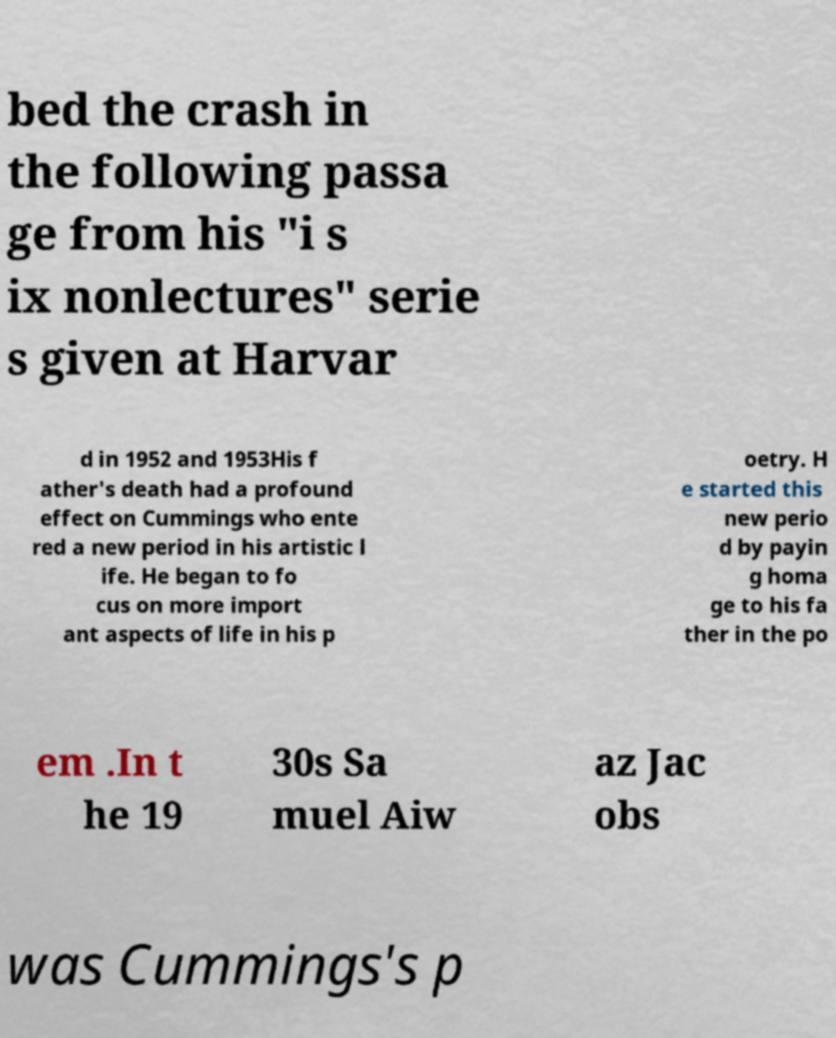Please identify and transcribe the text found in this image. bed the crash in the following passa ge from his "i s ix nonlectures" serie s given at Harvar d in 1952 and 1953His f ather's death had a profound effect on Cummings who ente red a new period in his artistic l ife. He began to fo cus on more import ant aspects of life in his p oetry. H e started this new perio d by payin g homa ge to his fa ther in the po em .In t he 19 30s Sa muel Aiw az Jac obs was Cummings's p 